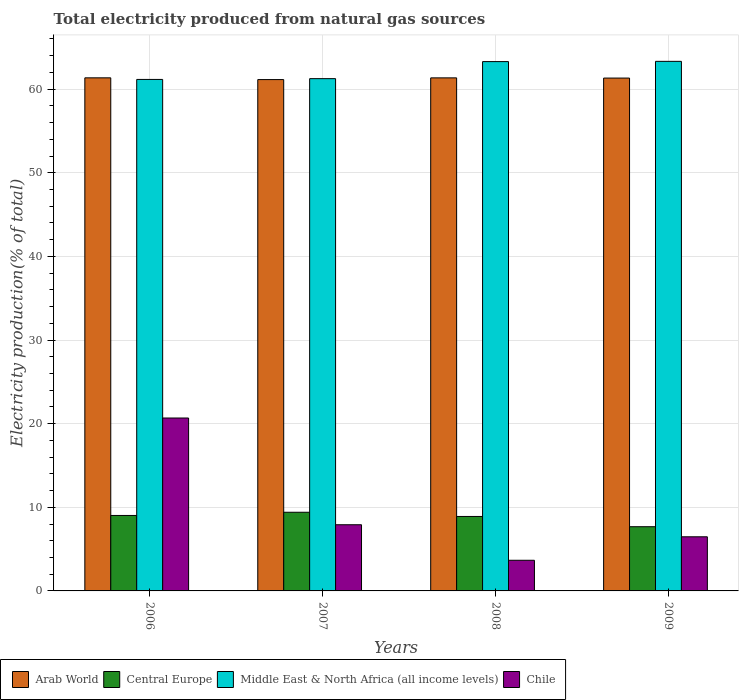How many different coloured bars are there?
Give a very brief answer. 4. Are the number of bars per tick equal to the number of legend labels?
Your response must be concise. Yes. Are the number of bars on each tick of the X-axis equal?
Make the answer very short. Yes. How many bars are there on the 2nd tick from the left?
Make the answer very short. 4. In how many cases, is the number of bars for a given year not equal to the number of legend labels?
Provide a short and direct response. 0. What is the total electricity produced in Chile in 2008?
Make the answer very short. 3.66. Across all years, what is the maximum total electricity produced in Central Europe?
Keep it short and to the point. 9.41. Across all years, what is the minimum total electricity produced in Central Europe?
Your response must be concise. 7.68. In which year was the total electricity produced in Chile minimum?
Ensure brevity in your answer.  2008. What is the total total electricity produced in Central Europe in the graph?
Provide a short and direct response. 35.01. What is the difference between the total electricity produced in Chile in 2006 and that in 2009?
Provide a short and direct response. 14.2. What is the difference between the total electricity produced in Chile in 2008 and the total electricity produced in Middle East & North Africa (all income levels) in 2006?
Offer a very short reply. -57.5. What is the average total electricity produced in Chile per year?
Provide a succinct answer. 9.68. In the year 2008, what is the difference between the total electricity produced in Middle East & North Africa (all income levels) and total electricity produced in Arab World?
Offer a very short reply. 1.94. In how many years, is the total electricity produced in Arab World greater than 50 %?
Make the answer very short. 4. What is the ratio of the total electricity produced in Arab World in 2006 to that in 2009?
Ensure brevity in your answer.  1. Is the total electricity produced in Chile in 2007 less than that in 2008?
Provide a short and direct response. No. Is the difference between the total electricity produced in Middle East & North Africa (all income levels) in 2006 and 2009 greater than the difference between the total electricity produced in Arab World in 2006 and 2009?
Your response must be concise. No. What is the difference between the highest and the second highest total electricity produced in Middle East & North Africa (all income levels)?
Offer a terse response. 0.03. What is the difference between the highest and the lowest total electricity produced in Central Europe?
Ensure brevity in your answer.  1.73. In how many years, is the total electricity produced in Arab World greater than the average total electricity produced in Arab World taken over all years?
Offer a terse response. 3. Is the sum of the total electricity produced in Middle East & North Africa (all income levels) in 2007 and 2009 greater than the maximum total electricity produced in Central Europe across all years?
Give a very brief answer. Yes. Is it the case that in every year, the sum of the total electricity produced in Chile and total electricity produced in Arab World is greater than the sum of total electricity produced in Middle East & North Africa (all income levels) and total electricity produced in Central Europe?
Your answer should be very brief. No. What does the 1st bar from the left in 2009 represents?
Your answer should be very brief. Arab World. What does the 1st bar from the right in 2006 represents?
Ensure brevity in your answer.  Chile. Is it the case that in every year, the sum of the total electricity produced in Chile and total electricity produced in Middle East & North Africa (all income levels) is greater than the total electricity produced in Arab World?
Your answer should be very brief. Yes. How many bars are there?
Ensure brevity in your answer.  16. Are all the bars in the graph horizontal?
Provide a succinct answer. No. Does the graph contain grids?
Make the answer very short. Yes. What is the title of the graph?
Your response must be concise. Total electricity produced from natural gas sources. What is the label or title of the X-axis?
Your answer should be compact. Years. What is the Electricity production(% of total) in Arab World in 2006?
Make the answer very short. 61.35. What is the Electricity production(% of total) of Central Europe in 2006?
Provide a short and direct response. 9.02. What is the Electricity production(% of total) of Middle East & North Africa (all income levels) in 2006?
Ensure brevity in your answer.  61.16. What is the Electricity production(% of total) in Chile in 2006?
Your answer should be compact. 20.68. What is the Electricity production(% of total) in Arab World in 2007?
Give a very brief answer. 61.14. What is the Electricity production(% of total) of Central Europe in 2007?
Your response must be concise. 9.41. What is the Electricity production(% of total) in Middle East & North Africa (all income levels) in 2007?
Offer a terse response. 61.26. What is the Electricity production(% of total) of Chile in 2007?
Keep it short and to the point. 7.91. What is the Electricity production(% of total) in Arab World in 2008?
Provide a succinct answer. 61.35. What is the Electricity production(% of total) in Central Europe in 2008?
Offer a very short reply. 8.9. What is the Electricity production(% of total) of Middle East & North Africa (all income levels) in 2008?
Your answer should be very brief. 63.29. What is the Electricity production(% of total) of Chile in 2008?
Your response must be concise. 3.66. What is the Electricity production(% of total) in Arab World in 2009?
Ensure brevity in your answer.  61.33. What is the Electricity production(% of total) in Central Europe in 2009?
Offer a very short reply. 7.68. What is the Electricity production(% of total) in Middle East & North Africa (all income levels) in 2009?
Provide a succinct answer. 63.32. What is the Electricity production(% of total) of Chile in 2009?
Your response must be concise. 6.47. Across all years, what is the maximum Electricity production(% of total) of Arab World?
Provide a short and direct response. 61.35. Across all years, what is the maximum Electricity production(% of total) of Central Europe?
Keep it short and to the point. 9.41. Across all years, what is the maximum Electricity production(% of total) of Middle East & North Africa (all income levels)?
Provide a short and direct response. 63.32. Across all years, what is the maximum Electricity production(% of total) of Chile?
Keep it short and to the point. 20.68. Across all years, what is the minimum Electricity production(% of total) of Arab World?
Ensure brevity in your answer.  61.14. Across all years, what is the minimum Electricity production(% of total) in Central Europe?
Offer a very short reply. 7.68. Across all years, what is the minimum Electricity production(% of total) of Middle East & North Africa (all income levels)?
Your response must be concise. 61.16. Across all years, what is the minimum Electricity production(% of total) of Chile?
Make the answer very short. 3.66. What is the total Electricity production(% of total) of Arab World in the graph?
Make the answer very short. 245.17. What is the total Electricity production(% of total) of Central Europe in the graph?
Offer a terse response. 35.01. What is the total Electricity production(% of total) of Middle East & North Africa (all income levels) in the graph?
Your response must be concise. 249.04. What is the total Electricity production(% of total) of Chile in the graph?
Your answer should be compact. 38.73. What is the difference between the Electricity production(% of total) in Arab World in 2006 and that in 2007?
Give a very brief answer. 0.21. What is the difference between the Electricity production(% of total) in Central Europe in 2006 and that in 2007?
Offer a very short reply. -0.38. What is the difference between the Electricity production(% of total) in Middle East & North Africa (all income levels) in 2006 and that in 2007?
Keep it short and to the point. -0.09. What is the difference between the Electricity production(% of total) in Chile in 2006 and that in 2007?
Your answer should be compact. 12.76. What is the difference between the Electricity production(% of total) in Arab World in 2006 and that in 2008?
Give a very brief answer. 0. What is the difference between the Electricity production(% of total) of Central Europe in 2006 and that in 2008?
Give a very brief answer. 0.12. What is the difference between the Electricity production(% of total) of Middle East & North Africa (all income levels) in 2006 and that in 2008?
Offer a terse response. -2.13. What is the difference between the Electricity production(% of total) in Chile in 2006 and that in 2008?
Ensure brevity in your answer.  17.01. What is the difference between the Electricity production(% of total) of Arab World in 2006 and that in 2009?
Your response must be concise. 0.03. What is the difference between the Electricity production(% of total) of Central Europe in 2006 and that in 2009?
Make the answer very short. 1.35. What is the difference between the Electricity production(% of total) in Middle East & North Africa (all income levels) in 2006 and that in 2009?
Provide a succinct answer. -2.16. What is the difference between the Electricity production(% of total) in Chile in 2006 and that in 2009?
Provide a short and direct response. 14.2. What is the difference between the Electricity production(% of total) in Arab World in 2007 and that in 2008?
Keep it short and to the point. -0.2. What is the difference between the Electricity production(% of total) in Central Europe in 2007 and that in 2008?
Keep it short and to the point. 0.5. What is the difference between the Electricity production(% of total) of Middle East & North Africa (all income levels) in 2007 and that in 2008?
Provide a succinct answer. -2.04. What is the difference between the Electricity production(% of total) of Chile in 2007 and that in 2008?
Your answer should be very brief. 4.25. What is the difference between the Electricity production(% of total) of Arab World in 2007 and that in 2009?
Give a very brief answer. -0.18. What is the difference between the Electricity production(% of total) of Central Europe in 2007 and that in 2009?
Offer a terse response. 1.73. What is the difference between the Electricity production(% of total) of Middle East & North Africa (all income levels) in 2007 and that in 2009?
Provide a succinct answer. -2.07. What is the difference between the Electricity production(% of total) in Chile in 2007 and that in 2009?
Provide a succinct answer. 1.44. What is the difference between the Electricity production(% of total) in Arab World in 2008 and that in 2009?
Provide a succinct answer. 0.02. What is the difference between the Electricity production(% of total) of Central Europe in 2008 and that in 2009?
Your response must be concise. 1.23. What is the difference between the Electricity production(% of total) of Middle East & North Africa (all income levels) in 2008 and that in 2009?
Your answer should be very brief. -0.03. What is the difference between the Electricity production(% of total) in Chile in 2008 and that in 2009?
Provide a short and direct response. -2.81. What is the difference between the Electricity production(% of total) in Arab World in 2006 and the Electricity production(% of total) in Central Europe in 2007?
Offer a very short reply. 51.95. What is the difference between the Electricity production(% of total) of Arab World in 2006 and the Electricity production(% of total) of Middle East & North Africa (all income levels) in 2007?
Keep it short and to the point. 0.1. What is the difference between the Electricity production(% of total) of Arab World in 2006 and the Electricity production(% of total) of Chile in 2007?
Ensure brevity in your answer.  53.44. What is the difference between the Electricity production(% of total) of Central Europe in 2006 and the Electricity production(% of total) of Middle East & North Africa (all income levels) in 2007?
Offer a very short reply. -52.23. What is the difference between the Electricity production(% of total) of Central Europe in 2006 and the Electricity production(% of total) of Chile in 2007?
Ensure brevity in your answer.  1.11. What is the difference between the Electricity production(% of total) of Middle East & North Africa (all income levels) in 2006 and the Electricity production(% of total) of Chile in 2007?
Provide a short and direct response. 53.25. What is the difference between the Electricity production(% of total) in Arab World in 2006 and the Electricity production(% of total) in Central Europe in 2008?
Your answer should be compact. 52.45. What is the difference between the Electricity production(% of total) in Arab World in 2006 and the Electricity production(% of total) in Middle East & North Africa (all income levels) in 2008?
Provide a short and direct response. -1.94. What is the difference between the Electricity production(% of total) in Arab World in 2006 and the Electricity production(% of total) in Chile in 2008?
Ensure brevity in your answer.  57.69. What is the difference between the Electricity production(% of total) of Central Europe in 2006 and the Electricity production(% of total) of Middle East & North Africa (all income levels) in 2008?
Your answer should be very brief. -54.27. What is the difference between the Electricity production(% of total) of Central Europe in 2006 and the Electricity production(% of total) of Chile in 2008?
Give a very brief answer. 5.36. What is the difference between the Electricity production(% of total) of Middle East & North Africa (all income levels) in 2006 and the Electricity production(% of total) of Chile in 2008?
Your response must be concise. 57.5. What is the difference between the Electricity production(% of total) in Arab World in 2006 and the Electricity production(% of total) in Central Europe in 2009?
Your response must be concise. 53.68. What is the difference between the Electricity production(% of total) in Arab World in 2006 and the Electricity production(% of total) in Middle East & North Africa (all income levels) in 2009?
Keep it short and to the point. -1.97. What is the difference between the Electricity production(% of total) in Arab World in 2006 and the Electricity production(% of total) in Chile in 2009?
Provide a succinct answer. 54.88. What is the difference between the Electricity production(% of total) of Central Europe in 2006 and the Electricity production(% of total) of Middle East & North Africa (all income levels) in 2009?
Provide a succinct answer. -54.3. What is the difference between the Electricity production(% of total) in Central Europe in 2006 and the Electricity production(% of total) in Chile in 2009?
Your response must be concise. 2.55. What is the difference between the Electricity production(% of total) of Middle East & North Africa (all income levels) in 2006 and the Electricity production(% of total) of Chile in 2009?
Offer a terse response. 54.69. What is the difference between the Electricity production(% of total) of Arab World in 2007 and the Electricity production(% of total) of Central Europe in 2008?
Your answer should be compact. 52.24. What is the difference between the Electricity production(% of total) in Arab World in 2007 and the Electricity production(% of total) in Middle East & North Africa (all income levels) in 2008?
Provide a short and direct response. -2.15. What is the difference between the Electricity production(% of total) in Arab World in 2007 and the Electricity production(% of total) in Chile in 2008?
Your answer should be compact. 57.48. What is the difference between the Electricity production(% of total) in Central Europe in 2007 and the Electricity production(% of total) in Middle East & North Africa (all income levels) in 2008?
Your answer should be very brief. -53.89. What is the difference between the Electricity production(% of total) of Central Europe in 2007 and the Electricity production(% of total) of Chile in 2008?
Offer a terse response. 5.74. What is the difference between the Electricity production(% of total) in Middle East & North Africa (all income levels) in 2007 and the Electricity production(% of total) in Chile in 2008?
Give a very brief answer. 57.59. What is the difference between the Electricity production(% of total) in Arab World in 2007 and the Electricity production(% of total) in Central Europe in 2009?
Make the answer very short. 53.47. What is the difference between the Electricity production(% of total) of Arab World in 2007 and the Electricity production(% of total) of Middle East & North Africa (all income levels) in 2009?
Keep it short and to the point. -2.18. What is the difference between the Electricity production(% of total) in Arab World in 2007 and the Electricity production(% of total) in Chile in 2009?
Provide a short and direct response. 54.67. What is the difference between the Electricity production(% of total) of Central Europe in 2007 and the Electricity production(% of total) of Middle East & North Africa (all income levels) in 2009?
Your response must be concise. -53.92. What is the difference between the Electricity production(% of total) in Central Europe in 2007 and the Electricity production(% of total) in Chile in 2009?
Give a very brief answer. 2.93. What is the difference between the Electricity production(% of total) of Middle East & North Africa (all income levels) in 2007 and the Electricity production(% of total) of Chile in 2009?
Keep it short and to the point. 54.78. What is the difference between the Electricity production(% of total) of Arab World in 2008 and the Electricity production(% of total) of Central Europe in 2009?
Give a very brief answer. 53.67. What is the difference between the Electricity production(% of total) of Arab World in 2008 and the Electricity production(% of total) of Middle East & North Africa (all income levels) in 2009?
Your response must be concise. -1.97. What is the difference between the Electricity production(% of total) in Arab World in 2008 and the Electricity production(% of total) in Chile in 2009?
Offer a very short reply. 54.88. What is the difference between the Electricity production(% of total) of Central Europe in 2008 and the Electricity production(% of total) of Middle East & North Africa (all income levels) in 2009?
Ensure brevity in your answer.  -54.42. What is the difference between the Electricity production(% of total) of Central Europe in 2008 and the Electricity production(% of total) of Chile in 2009?
Provide a short and direct response. 2.43. What is the difference between the Electricity production(% of total) of Middle East & North Africa (all income levels) in 2008 and the Electricity production(% of total) of Chile in 2009?
Make the answer very short. 56.82. What is the average Electricity production(% of total) of Arab World per year?
Give a very brief answer. 61.29. What is the average Electricity production(% of total) of Central Europe per year?
Ensure brevity in your answer.  8.75. What is the average Electricity production(% of total) in Middle East & North Africa (all income levels) per year?
Provide a succinct answer. 62.26. What is the average Electricity production(% of total) of Chile per year?
Provide a short and direct response. 9.68. In the year 2006, what is the difference between the Electricity production(% of total) in Arab World and Electricity production(% of total) in Central Europe?
Offer a very short reply. 52.33. In the year 2006, what is the difference between the Electricity production(% of total) in Arab World and Electricity production(% of total) in Middle East & North Africa (all income levels)?
Provide a succinct answer. 0.19. In the year 2006, what is the difference between the Electricity production(% of total) in Arab World and Electricity production(% of total) in Chile?
Your response must be concise. 40.68. In the year 2006, what is the difference between the Electricity production(% of total) in Central Europe and Electricity production(% of total) in Middle East & North Africa (all income levels)?
Give a very brief answer. -52.14. In the year 2006, what is the difference between the Electricity production(% of total) of Central Europe and Electricity production(% of total) of Chile?
Keep it short and to the point. -11.65. In the year 2006, what is the difference between the Electricity production(% of total) of Middle East & North Africa (all income levels) and Electricity production(% of total) of Chile?
Your answer should be compact. 40.49. In the year 2007, what is the difference between the Electricity production(% of total) in Arab World and Electricity production(% of total) in Central Europe?
Your answer should be compact. 51.74. In the year 2007, what is the difference between the Electricity production(% of total) of Arab World and Electricity production(% of total) of Middle East & North Africa (all income levels)?
Your answer should be very brief. -0.11. In the year 2007, what is the difference between the Electricity production(% of total) of Arab World and Electricity production(% of total) of Chile?
Provide a short and direct response. 53.23. In the year 2007, what is the difference between the Electricity production(% of total) of Central Europe and Electricity production(% of total) of Middle East & North Africa (all income levels)?
Your answer should be very brief. -51.85. In the year 2007, what is the difference between the Electricity production(% of total) of Central Europe and Electricity production(% of total) of Chile?
Provide a succinct answer. 1.49. In the year 2007, what is the difference between the Electricity production(% of total) of Middle East & North Africa (all income levels) and Electricity production(% of total) of Chile?
Ensure brevity in your answer.  53.34. In the year 2008, what is the difference between the Electricity production(% of total) in Arab World and Electricity production(% of total) in Central Europe?
Your response must be concise. 52.44. In the year 2008, what is the difference between the Electricity production(% of total) in Arab World and Electricity production(% of total) in Middle East & North Africa (all income levels)?
Provide a short and direct response. -1.94. In the year 2008, what is the difference between the Electricity production(% of total) in Arab World and Electricity production(% of total) in Chile?
Make the answer very short. 57.68. In the year 2008, what is the difference between the Electricity production(% of total) in Central Europe and Electricity production(% of total) in Middle East & North Africa (all income levels)?
Your answer should be very brief. -54.39. In the year 2008, what is the difference between the Electricity production(% of total) of Central Europe and Electricity production(% of total) of Chile?
Provide a short and direct response. 5.24. In the year 2008, what is the difference between the Electricity production(% of total) in Middle East & North Africa (all income levels) and Electricity production(% of total) in Chile?
Offer a very short reply. 59.63. In the year 2009, what is the difference between the Electricity production(% of total) of Arab World and Electricity production(% of total) of Central Europe?
Give a very brief answer. 53.65. In the year 2009, what is the difference between the Electricity production(% of total) of Arab World and Electricity production(% of total) of Middle East & North Africa (all income levels)?
Your answer should be compact. -2. In the year 2009, what is the difference between the Electricity production(% of total) of Arab World and Electricity production(% of total) of Chile?
Your response must be concise. 54.85. In the year 2009, what is the difference between the Electricity production(% of total) in Central Europe and Electricity production(% of total) in Middle East & North Africa (all income levels)?
Your answer should be very brief. -55.65. In the year 2009, what is the difference between the Electricity production(% of total) of Central Europe and Electricity production(% of total) of Chile?
Ensure brevity in your answer.  1.21. In the year 2009, what is the difference between the Electricity production(% of total) of Middle East & North Africa (all income levels) and Electricity production(% of total) of Chile?
Offer a terse response. 56.85. What is the ratio of the Electricity production(% of total) in Arab World in 2006 to that in 2007?
Offer a very short reply. 1. What is the ratio of the Electricity production(% of total) in Central Europe in 2006 to that in 2007?
Make the answer very short. 0.96. What is the ratio of the Electricity production(% of total) in Chile in 2006 to that in 2007?
Ensure brevity in your answer.  2.61. What is the ratio of the Electricity production(% of total) in Central Europe in 2006 to that in 2008?
Your answer should be compact. 1.01. What is the ratio of the Electricity production(% of total) in Middle East & North Africa (all income levels) in 2006 to that in 2008?
Ensure brevity in your answer.  0.97. What is the ratio of the Electricity production(% of total) of Chile in 2006 to that in 2008?
Provide a short and direct response. 5.64. What is the ratio of the Electricity production(% of total) of Arab World in 2006 to that in 2009?
Keep it short and to the point. 1. What is the ratio of the Electricity production(% of total) of Central Europe in 2006 to that in 2009?
Provide a short and direct response. 1.18. What is the ratio of the Electricity production(% of total) in Middle East & North Africa (all income levels) in 2006 to that in 2009?
Provide a succinct answer. 0.97. What is the ratio of the Electricity production(% of total) of Chile in 2006 to that in 2009?
Provide a succinct answer. 3.19. What is the ratio of the Electricity production(% of total) of Central Europe in 2007 to that in 2008?
Your answer should be very brief. 1.06. What is the ratio of the Electricity production(% of total) in Middle East & North Africa (all income levels) in 2007 to that in 2008?
Offer a terse response. 0.97. What is the ratio of the Electricity production(% of total) in Chile in 2007 to that in 2008?
Offer a very short reply. 2.16. What is the ratio of the Electricity production(% of total) in Central Europe in 2007 to that in 2009?
Keep it short and to the point. 1.23. What is the ratio of the Electricity production(% of total) of Middle East & North Africa (all income levels) in 2007 to that in 2009?
Your answer should be very brief. 0.97. What is the ratio of the Electricity production(% of total) in Chile in 2007 to that in 2009?
Make the answer very short. 1.22. What is the ratio of the Electricity production(% of total) of Arab World in 2008 to that in 2009?
Your answer should be very brief. 1. What is the ratio of the Electricity production(% of total) of Central Europe in 2008 to that in 2009?
Your response must be concise. 1.16. What is the ratio of the Electricity production(% of total) in Chile in 2008 to that in 2009?
Your answer should be compact. 0.57. What is the difference between the highest and the second highest Electricity production(% of total) in Arab World?
Make the answer very short. 0. What is the difference between the highest and the second highest Electricity production(% of total) in Central Europe?
Your answer should be compact. 0.38. What is the difference between the highest and the second highest Electricity production(% of total) in Middle East & North Africa (all income levels)?
Your response must be concise. 0.03. What is the difference between the highest and the second highest Electricity production(% of total) of Chile?
Ensure brevity in your answer.  12.76. What is the difference between the highest and the lowest Electricity production(% of total) of Arab World?
Your answer should be very brief. 0.21. What is the difference between the highest and the lowest Electricity production(% of total) in Central Europe?
Your response must be concise. 1.73. What is the difference between the highest and the lowest Electricity production(% of total) of Middle East & North Africa (all income levels)?
Give a very brief answer. 2.16. What is the difference between the highest and the lowest Electricity production(% of total) of Chile?
Your response must be concise. 17.01. 